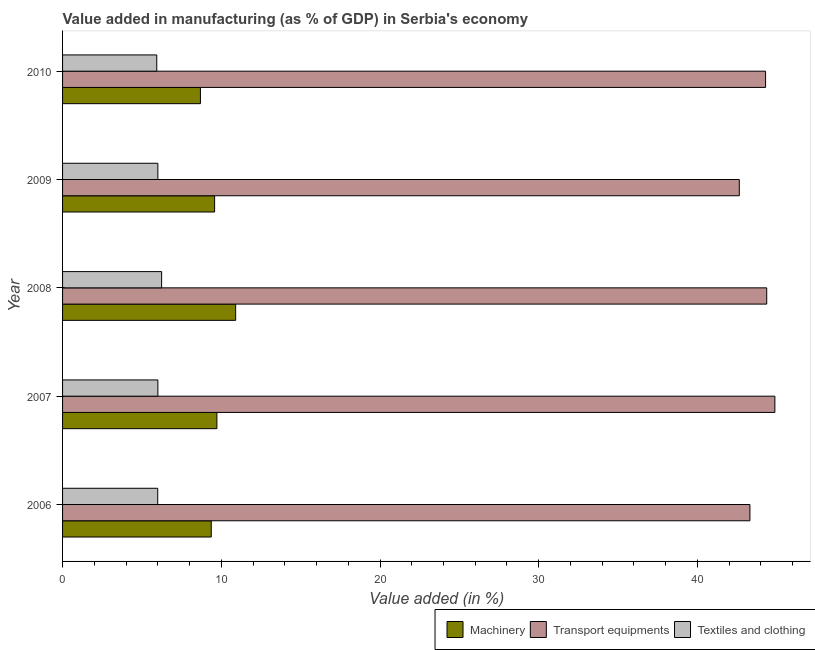How many bars are there on the 3rd tick from the bottom?
Your response must be concise. 3. What is the label of the 5th group of bars from the top?
Make the answer very short. 2006. In how many cases, is the number of bars for a given year not equal to the number of legend labels?
Give a very brief answer. 0. What is the value added in manufacturing transport equipments in 2010?
Your response must be concise. 44.29. Across all years, what is the maximum value added in manufacturing transport equipments?
Offer a terse response. 44.88. Across all years, what is the minimum value added in manufacturing textile and clothing?
Give a very brief answer. 5.94. What is the total value added in manufacturing machinery in the graph?
Provide a succinct answer. 48.26. What is the difference between the value added in manufacturing textile and clothing in 2006 and that in 2008?
Make the answer very short. -0.25. What is the difference between the value added in manufacturing transport equipments in 2010 and the value added in manufacturing textile and clothing in 2009?
Provide a succinct answer. 38.29. What is the average value added in manufacturing transport equipments per year?
Provide a succinct answer. 43.9. In the year 2006, what is the difference between the value added in manufacturing transport equipments and value added in manufacturing machinery?
Your answer should be very brief. 33.94. What is the ratio of the value added in manufacturing textile and clothing in 2007 to that in 2009?
Ensure brevity in your answer.  1. What is the difference between the highest and the second highest value added in manufacturing textile and clothing?
Provide a succinct answer. 0.24. What is the difference between the highest and the lowest value added in manufacturing machinery?
Your answer should be compact. 2.22. In how many years, is the value added in manufacturing textile and clothing greater than the average value added in manufacturing textile and clothing taken over all years?
Your answer should be compact. 1. What does the 2nd bar from the top in 2009 represents?
Your answer should be compact. Transport equipments. What does the 2nd bar from the bottom in 2009 represents?
Your response must be concise. Transport equipments. How many bars are there?
Ensure brevity in your answer.  15. Are all the bars in the graph horizontal?
Keep it short and to the point. Yes. What is the difference between two consecutive major ticks on the X-axis?
Ensure brevity in your answer.  10. Are the values on the major ticks of X-axis written in scientific E-notation?
Your response must be concise. No. Does the graph contain grids?
Provide a short and direct response. No. How many legend labels are there?
Your response must be concise. 3. What is the title of the graph?
Your answer should be very brief. Value added in manufacturing (as % of GDP) in Serbia's economy. Does "Resident buildings and public services" appear as one of the legend labels in the graph?
Your answer should be compact. No. What is the label or title of the X-axis?
Ensure brevity in your answer.  Value added (in %). What is the Value added (in %) of Machinery in 2006?
Offer a very short reply. 9.37. What is the Value added (in %) in Transport equipments in 2006?
Offer a terse response. 43.31. What is the Value added (in %) in Textiles and clothing in 2006?
Provide a short and direct response. 6. What is the Value added (in %) in Machinery in 2007?
Provide a short and direct response. 9.72. What is the Value added (in %) of Transport equipments in 2007?
Keep it short and to the point. 44.88. What is the Value added (in %) of Textiles and clothing in 2007?
Offer a very short reply. 6.01. What is the Value added (in %) of Machinery in 2008?
Give a very brief answer. 10.91. What is the Value added (in %) of Transport equipments in 2008?
Give a very brief answer. 44.37. What is the Value added (in %) of Textiles and clothing in 2008?
Provide a succinct answer. 6.24. What is the Value added (in %) of Machinery in 2009?
Provide a short and direct response. 9.58. What is the Value added (in %) in Transport equipments in 2009?
Provide a succinct answer. 42.64. What is the Value added (in %) of Textiles and clothing in 2009?
Provide a short and direct response. 6. What is the Value added (in %) of Machinery in 2010?
Offer a terse response. 8.69. What is the Value added (in %) of Transport equipments in 2010?
Your answer should be very brief. 44.29. What is the Value added (in %) in Textiles and clothing in 2010?
Ensure brevity in your answer.  5.94. Across all years, what is the maximum Value added (in %) of Machinery?
Give a very brief answer. 10.91. Across all years, what is the maximum Value added (in %) of Transport equipments?
Offer a terse response. 44.88. Across all years, what is the maximum Value added (in %) in Textiles and clothing?
Provide a short and direct response. 6.24. Across all years, what is the minimum Value added (in %) of Machinery?
Your response must be concise. 8.69. Across all years, what is the minimum Value added (in %) of Transport equipments?
Ensure brevity in your answer.  42.64. Across all years, what is the minimum Value added (in %) in Textiles and clothing?
Your answer should be very brief. 5.94. What is the total Value added (in %) of Machinery in the graph?
Your answer should be very brief. 48.26. What is the total Value added (in %) of Transport equipments in the graph?
Make the answer very short. 219.49. What is the total Value added (in %) in Textiles and clothing in the graph?
Ensure brevity in your answer.  30.18. What is the difference between the Value added (in %) of Machinery in 2006 and that in 2007?
Ensure brevity in your answer.  -0.36. What is the difference between the Value added (in %) of Transport equipments in 2006 and that in 2007?
Give a very brief answer. -1.57. What is the difference between the Value added (in %) in Textiles and clothing in 2006 and that in 2007?
Make the answer very short. -0.01. What is the difference between the Value added (in %) of Machinery in 2006 and that in 2008?
Ensure brevity in your answer.  -1.54. What is the difference between the Value added (in %) in Transport equipments in 2006 and that in 2008?
Make the answer very short. -1.06. What is the difference between the Value added (in %) of Textiles and clothing in 2006 and that in 2008?
Your response must be concise. -0.25. What is the difference between the Value added (in %) of Machinery in 2006 and that in 2009?
Offer a very short reply. -0.21. What is the difference between the Value added (in %) of Transport equipments in 2006 and that in 2009?
Your answer should be very brief. 0.67. What is the difference between the Value added (in %) of Textiles and clothing in 2006 and that in 2009?
Ensure brevity in your answer.  -0.01. What is the difference between the Value added (in %) in Machinery in 2006 and that in 2010?
Provide a short and direct response. 0.68. What is the difference between the Value added (in %) in Transport equipments in 2006 and that in 2010?
Provide a succinct answer. -0.99. What is the difference between the Value added (in %) of Textiles and clothing in 2006 and that in 2010?
Your answer should be very brief. 0.06. What is the difference between the Value added (in %) in Machinery in 2007 and that in 2008?
Keep it short and to the point. -1.18. What is the difference between the Value added (in %) of Transport equipments in 2007 and that in 2008?
Ensure brevity in your answer.  0.51. What is the difference between the Value added (in %) in Textiles and clothing in 2007 and that in 2008?
Offer a very short reply. -0.24. What is the difference between the Value added (in %) of Machinery in 2007 and that in 2009?
Make the answer very short. 0.14. What is the difference between the Value added (in %) in Transport equipments in 2007 and that in 2009?
Offer a terse response. 2.24. What is the difference between the Value added (in %) of Textiles and clothing in 2007 and that in 2009?
Your response must be concise. 0. What is the difference between the Value added (in %) of Machinery in 2007 and that in 2010?
Ensure brevity in your answer.  1.04. What is the difference between the Value added (in %) in Transport equipments in 2007 and that in 2010?
Your response must be concise. 0.59. What is the difference between the Value added (in %) in Textiles and clothing in 2007 and that in 2010?
Ensure brevity in your answer.  0.07. What is the difference between the Value added (in %) in Machinery in 2008 and that in 2009?
Your response must be concise. 1.33. What is the difference between the Value added (in %) in Transport equipments in 2008 and that in 2009?
Provide a succinct answer. 1.73. What is the difference between the Value added (in %) in Textiles and clothing in 2008 and that in 2009?
Your response must be concise. 0.24. What is the difference between the Value added (in %) in Machinery in 2008 and that in 2010?
Offer a very short reply. 2.22. What is the difference between the Value added (in %) of Transport equipments in 2008 and that in 2010?
Make the answer very short. 0.07. What is the difference between the Value added (in %) in Textiles and clothing in 2008 and that in 2010?
Your answer should be compact. 0.31. What is the difference between the Value added (in %) in Machinery in 2009 and that in 2010?
Give a very brief answer. 0.89. What is the difference between the Value added (in %) of Transport equipments in 2009 and that in 2010?
Your answer should be compact. -1.66. What is the difference between the Value added (in %) of Textiles and clothing in 2009 and that in 2010?
Offer a very short reply. 0.07. What is the difference between the Value added (in %) in Machinery in 2006 and the Value added (in %) in Transport equipments in 2007?
Provide a short and direct response. -35.51. What is the difference between the Value added (in %) of Machinery in 2006 and the Value added (in %) of Textiles and clothing in 2007?
Your answer should be compact. 3.36. What is the difference between the Value added (in %) in Transport equipments in 2006 and the Value added (in %) in Textiles and clothing in 2007?
Offer a terse response. 37.3. What is the difference between the Value added (in %) of Machinery in 2006 and the Value added (in %) of Transport equipments in 2008?
Offer a terse response. -35. What is the difference between the Value added (in %) of Machinery in 2006 and the Value added (in %) of Textiles and clothing in 2008?
Keep it short and to the point. 3.13. What is the difference between the Value added (in %) in Transport equipments in 2006 and the Value added (in %) in Textiles and clothing in 2008?
Offer a very short reply. 37.07. What is the difference between the Value added (in %) of Machinery in 2006 and the Value added (in %) of Transport equipments in 2009?
Offer a very short reply. -33.27. What is the difference between the Value added (in %) in Machinery in 2006 and the Value added (in %) in Textiles and clothing in 2009?
Offer a very short reply. 3.36. What is the difference between the Value added (in %) in Transport equipments in 2006 and the Value added (in %) in Textiles and clothing in 2009?
Give a very brief answer. 37.3. What is the difference between the Value added (in %) of Machinery in 2006 and the Value added (in %) of Transport equipments in 2010?
Your response must be concise. -34.93. What is the difference between the Value added (in %) of Machinery in 2006 and the Value added (in %) of Textiles and clothing in 2010?
Keep it short and to the point. 3.43. What is the difference between the Value added (in %) of Transport equipments in 2006 and the Value added (in %) of Textiles and clothing in 2010?
Ensure brevity in your answer.  37.37. What is the difference between the Value added (in %) of Machinery in 2007 and the Value added (in %) of Transport equipments in 2008?
Your response must be concise. -34.64. What is the difference between the Value added (in %) in Machinery in 2007 and the Value added (in %) in Textiles and clothing in 2008?
Provide a succinct answer. 3.48. What is the difference between the Value added (in %) in Transport equipments in 2007 and the Value added (in %) in Textiles and clothing in 2008?
Make the answer very short. 38.64. What is the difference between the Value added (in %) of Machinery in 2007 and the Value added (in %) of Transport equipments in 2009?
Ensure brevity in your answer.  -32.92. What is the difference between the Value added (in %) in Machinery in 2007 and the Value added (in %) in Textiles and clothing in 2009?
Your answer should be very brief. 3.72. What is the difference between the Value added (in %) in Transport equipments in 2007 and the Value added (in %) in Textiles and clothing in 2009?
Your response must be concise. 38.88. What is the difference between the Value added (in %) in Machinery in 2007 and the Value added (in %) in Transport equipments in 2010?
Provide a succinct answer. -34.57. What is the difference between the Value added (in %) in Machinery in 2007 and the Value added (in %) in Textiles and clothing in 2010?
Make the answer very short. 3.79. What is the difference between the Value added (in %) in Transport equipments in 2007 and the Value added (in %) in Textiles and clothing in 2010?
Your answer should be compact. 38.94. What is the difference between the Value added (in %) in Machinery in 2008 and the Value added (in %) in Transport equipments in 2009?
Provide a succinct answer. -31.73. What is the difference between the Value added (in %) in Machinery in 2008 and the Value added (in %) in Textiles and clothing in 2009?
Offer a very short reply. 4.9. What is the difference between the Value added (in %) in Transport equipments in 2008 and the Value added (in %) in Textiles and clothing in 2009?
Give a very brief answer. 38.36. What is the difference between the Value added (in %) in Machinery in 2008 and the Value added (in %) in Transport equipments in 2010?
Your answer should be very brief. -33.39. What is the difference between the Value added (in %) in Machinery in 2008 and the Value added (in %) in Textiles and clothing in 2010?
Ensure brevity in your answer.  4.97. What is the difference between the Value added (in %) of Transport equipments in 2008 and the Value added (in %) of Textiles and clothing in 2010?
Keep it short and to the point. 38.43. What is the difference between the Value added (in %) of Machinery in 2009 and the Value added (in %) of Transport equipments in 2010?
Provide a succinct answer. -34.71. What is the difference between the Value added (in %) in Machinery in 2009 and the Value added (in %) in Textiles and clothing in 2010?
Your answer should be very brief. 3.64. What is the difference between the Value added (in %) of Transport equipments in 2009 and the Value added (in %) of Textiles and clothing in 2010?
Your answer should be very brief. 36.7. What is the average Value added (in %) in Machinery per year?
Give a very brief answer. 9.65. What is the average Value added (in %) of Transport equipments per year?
Keep it short and to the point. 43.9. What is the average Value added (in %) of Textiles and clothing per year?
Keep it short and to the point. 6.04. In the year 2006, what is the difference between the Value added (in %) of Machinery and Value added (in %) of Transport equipments?
Your response must be concise. -33.94. In the year 2006, what is the difference between the Value added (in %) in Machinery and Value added (in %) in Textiles and clothing?
Offer a terse response. 3.37. In the year 2006, what is the difference between the Value added (in %) of Transport equipments and Value added (in %) of Textiles and clothing?
Keep it short and to the point. 37.31. In the year 2007, what is the difference between the Value added (in %) in Machinery and Value added (in %) in Transport equipments?
Provide a short and direct response. -35.16. In the year 2007, what is the difference between the Value added (in %) in Machinery and Value added (in %) in Textiles and clothing?
Your response must be concise. 3.72. In the year 2007, what is the difference between the Value added (in %) in Transport equipments and Value added (in %) in Textiles and clothing?
Offer a terse response. 38.87. In the year 2008, what is the difference between the Value added (in %) of Machinery and Value added (in %) of Transport equipments?
Offer a terse response. -33.46. In the year 2008, what is the difference between the Value added (in %) in Machinery and Value added (in %) in Textiles and clothing?
Provide a short and direct response. 4.66. In the year 2008, what is the difference between the Value added (in %) of Transport equipments and Value added (in %) of Textiles and clothing?
Your answer should be very brief. 38.12. In the year 2009, what is the difference between the Value added (in %) in Machinery and Value added (in %) in Transport equipments?
Offer a very short reply. -33.06. In the year 2009, what is the difference between the Value added (in %) in Machinery and Value added (in %) in Textiles and clothing?
Your response must be concise. 3.58. In the year 2009, what is the difference between the Value added (in %) of Transport equipments and Value added (in %) of Textiles and clothing?
Make the answer very short. 36.64. In the year 2010, what is the difference between the Value added (in %) in Machinery and Value added (in %) in Transport equipments?
Offer a very short reply. -35.61. In the year 2010, what is the difference between the Value added (in %) in Machinery and Value added (in %) in Textiles and clothing?
Your answer should be compact. 2.75. In the year 2010, what is the difference between the Value added (in %) in Transport equipments and Value added (in %) in Textiles and clothing?
Offer a very short reply. 38.36. What is the ratio of the Value added (in %) in Machinery in 2006 to that in 2007?
Provide a short and direct response. 0.96. What is the ratio of the Value added (in %) of Transport equipments in 2006 to that in 2007?
Ensure brevity in your answer.  0.96. What is the ratio of the Value added (in %) in Machinery in 2006 to that in 2008?
Offer a very short reply. 0.86. What is the ratio of the Value added (in %) in Transport equipments in 2006 to that in 2008?
Make the answer very short. 0.98. What is the ratio of the Value added (in %) in Textiles and clothing in 2006 to that in 2008?
Provide a short and direct response. 0.96. What is the ratio of the Value added (in %) of Machinery in 2006 to that in 2009?
Your answer should be very brief. 0.98. What is the ratio of the Value added (in %) in Transport equipments in 2006 to that in 2009?
Offer a very short reply. 1.02. What is the ratio of the Value added (in %) in Machinery in 2006 to that in 2010?
Provide a succinct answer. 1.08. What is the ratio of the Value added (in %) in Transport equipments in 2006 to that in 2010?
Provide a short and direct response. 0.98. What is the ratio of the Value added (in %) in Machinery in 2007 to that in 2008?
Provide a short and direct response. 0.89. What is the ratio of the Value added (in %) of Transport equipments in 2007 to that in 2008?
Offer a very short reply. 1.01. What is the ratio of the Value added (in %) in Textiles and clothing in 2007 to that in 2008?
Offer a very short reply. 0.96. What is the ratio of the Value added (in %) of Machinery in 2007 to that in 2009?
Provide a short and direct response. 1.01. What is the ratio of the Value added (in %) in Transport equipments in 2007 to that in 2009?
Provide a succinct answer. 1.05. What is the ratio of the Value added (in %) of Machinery in 2007 to that in 2010?
Keep it short and to the point. 1.12. What is the ratio of the Value added (in %) of Transport equipments in 2007 to that in 2010?
Your response must be concise. 1.01. What is the ratio of the Value added (in %) in Textiles and clothing in 2007 to that in 2010?
Give a very brief answer. 1.01. What is the ratio of the Value added (in %) of Machinery in 2008 to that in 2009?
Keep it short and to the point. 1.14. What is the ratio of the Value added (in %) of Transport equipments in 2008 to that in 2009?
Your answer should be very brief. 1.04. What is the ratio of the Value added (in %) of Textiles and clothing in 2008 to that in 2009?
Provide a short and direct response. 1.04. What is the ratio of the Value added (in %) in Machinery in 2008 to that in 2010?
Ensure brevity in your answer.  1.26. What is the ratio of the Value added (in %) in Textiles and clothing in 2008 to that in 2010?
Offer a very short reply. 1.05. What is the ratio of the Value added (in %) in Machinery in 2009 to that in 2010?
Make the answer very short. 1.1. What is the ratio of the Value added (in %) in Transport equipments in 2009 to that in 2010?
Give a very brief answer. 0.96. What is the ratio of the Value added (in %) in Textiles and clothing in 2009 to that in 2010?
Make the answer very short. 1.01. What is the difference between the highest and the second highest Value added (in %) in Machinery?
Provide a short and direct response. 1.18. What is the difference between the highest and the second highest Value added (in %) of Transport equipments?
Ensure brevity in your answer.  0.51. What is the difference between the highest and the second highest Value added (in %) in Textiles and clothing?
Ensure brevity in your answer.  0.24. What is the difference between the highest and the lowest Value added (in %) in Machinery?
Your answer should be compact. 2.22. What is the difference between the highest and the lowest Value added (in %) of Transport equipments?
Your answer should be very brief. 2.24. What is the difference between the highest and the lowest Value added (in %) of Textiles and clothing?
Offer a very short reply. 0.31. 